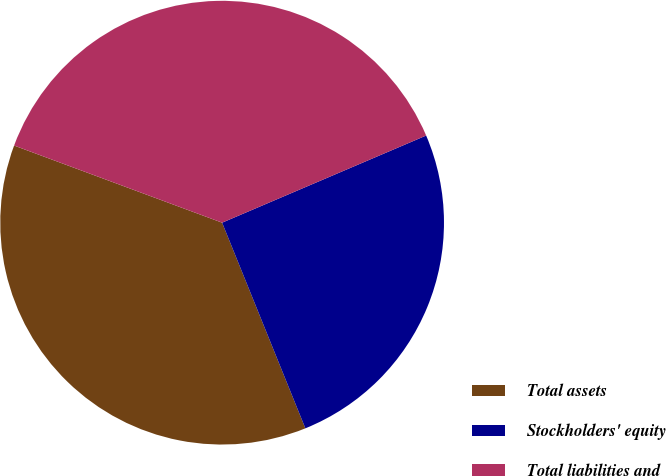<chart> <loc_0><loc_0><loc_500><loc_500><pie_chart><fcel>Total assets<fcel>Stockholders' equity<fcel>Total liabilities and<nl><fcel>36.77%<fcel>25.3%<fcel>37.92%<nl></chart> 